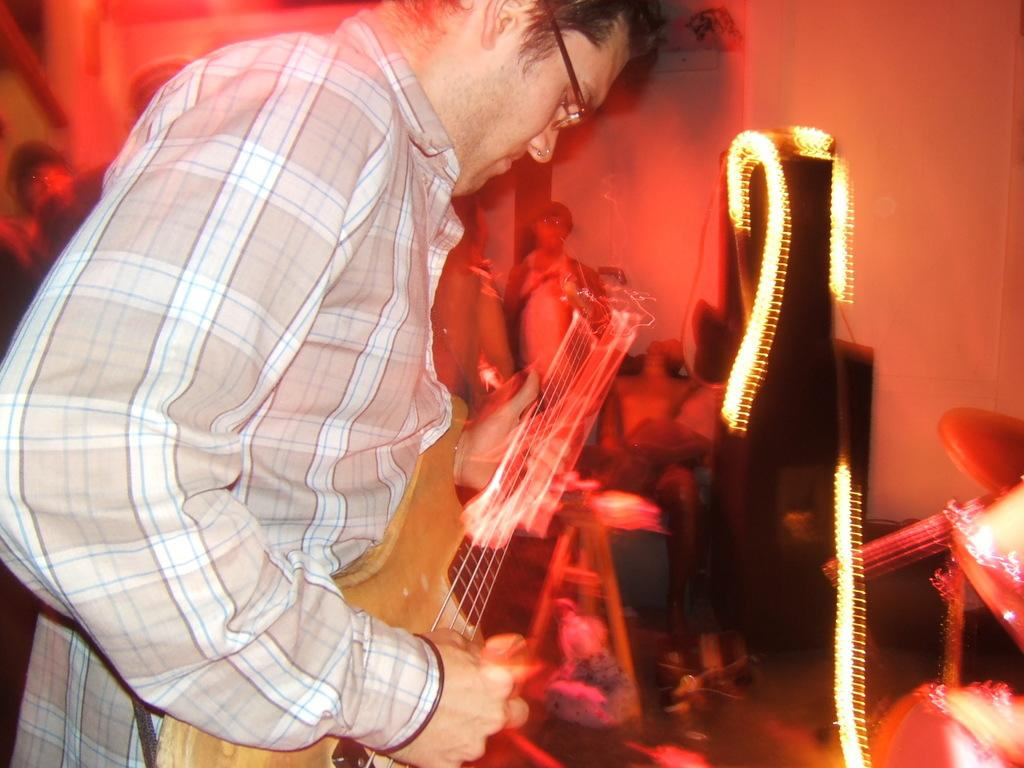What is the main subject of the image? The main subject of the image is a man. What is the man wearing in the image? The man is wearing a checked shirt. What is the man doing in the image? The man is playing a guitar. What accessory is the man wearing in the image? The man is wearing spectacles. What natural phenomenon can be seen in the image? There are lightnings visible in the image. Can you see any cobwebs in the image? There is no mention of cobwebs in the provided facts, and therefore it cannot be determined if any are present in the image. What type of duck is sitting next to the man in the image? There is no mention of a duck in the provided facts, and therefore it cannot be determined if any are present in the image. 